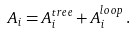Convert formula to latex. <formula><loc_0><loc_0><loc_500><loc_500>A _ { i } = A _ { i } ^ { t r e e } + A _ { i } ^ { l o o p } \, .</formula> 